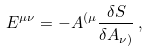<formula> <loc_0><loc_0><loc_500><loc_500>E ^ { \mu \nu } = - A ^ { ( \mu } { \frac { \delta S } { \delta A _ { \nu ) } } } \, ,</formula> 